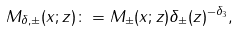<formula> <loc_0><loc_0><loc_500><loc_500>M _ { \delta , \pm } ( x ; z ) \colon = M _ { \pm } ( x ; z ) \delta _ { \pm } ( z ) ^ { - \delta _ { 3 } } ,</formula> 